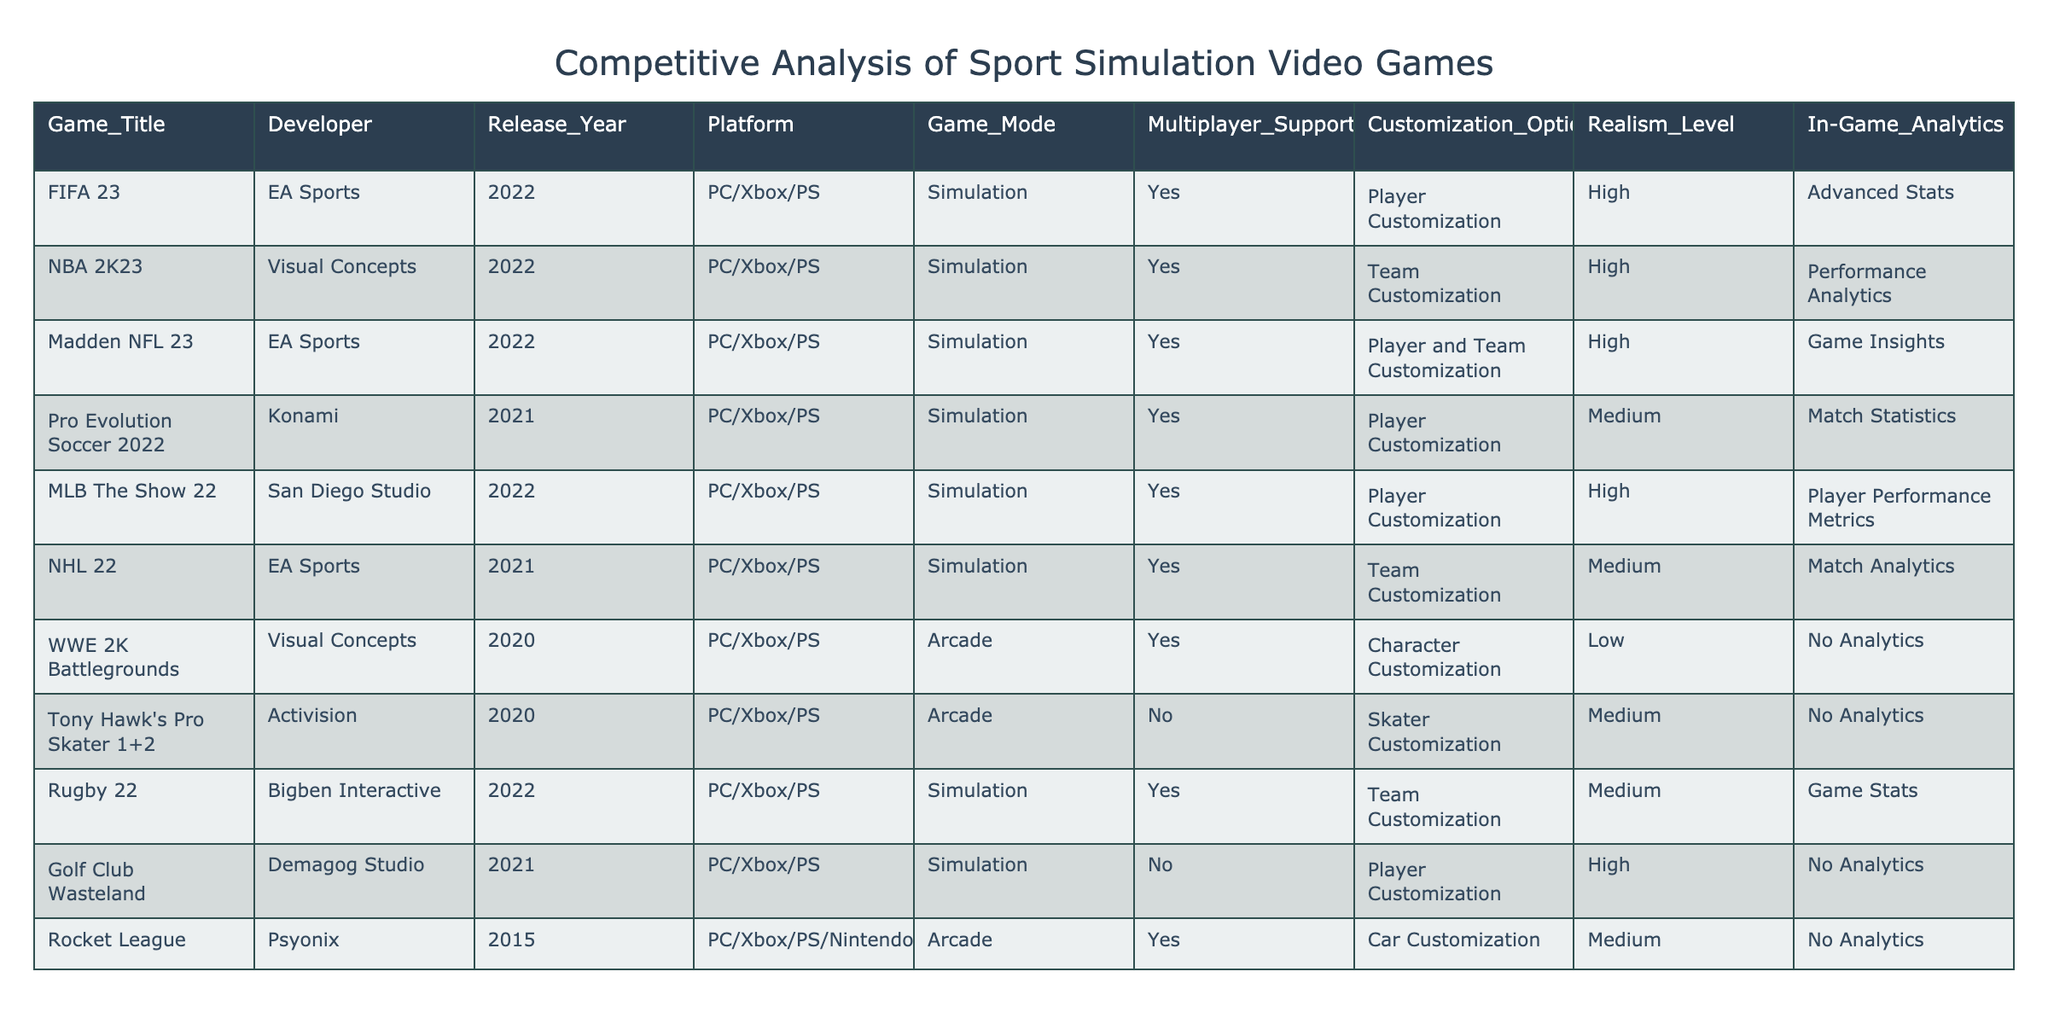What game was released in 2022 with the highest realism level? From the table, we can see that both FIFA 23, NBA 2K23, Madden NFL 23, and MLB The Show 22 were released in 2022. Among these, FIFA 23, NBA 2K23, Madden NFL 23, and MLB The Show 22 all have a high realism level, but since we are looking for the right answer we can say all four belong to this section without limitations according to the data.
Answer: FIFA 23, NBA 2K23, Madden NFL 23, MLB The Show 22 Which game developer produced the most games in the table? By examining the developer column, we can count the games associated with each developer. EA Sports has three titles: FIFA 23, Madden NFL 23, and NHL 22. Visual Concepts has two titles: NBA 2K23 and WWE 2K Battlegrounds. Other developers have one title each. Therefore, the count of games developed by EA Sports is the highest.
Answer: EA Sports What is the average realism level of simulation games in the table? The realism levels for simulation games in the table are high (FIFA 23, NBA 2K23, Madden NFL 23, MLB The Show 22), medium (Pro Evolution Soccer 2022, NHL 22, Rugby 22), and high (Golf Club Wasteland). To quantify these, we can assign values: 3 for high, 2 for medium, and 1 for low. Thus, the average realism level can be calculated as follows: (3 + 3 + 3 + 3 + 2 + 2 + 2) / 7 = 2.57 (approximately 2.6 when considering two decimal precision).
Answer: 2.6 Is there a game that offers customization options but has no in-game analytics? The table shows that Rocket League and Golf Club Wasteland offer customization options and neither has in-game analytics. Therefore, there are indeed games that fit this criterion.
Answer: Yes Which multiplayer game with the highest customization options is not a simulation game? The table lists WWE 2K Battlegrounds and Tony Hawk's Pro Skater 1+2 as arcade games with multiplayer support. Among these, WWE 2K Battlegrounds has character customization, while Tony Hawk's Pro Skater 1+2 features skater customization. Since both have customization, we will consider the total level of customization to determine the better choice. In this case, character customization in WWE 2K Battlegrounds represents the highest customization option among the arcade games.
Answer: WWE 2K Battlegrounds 